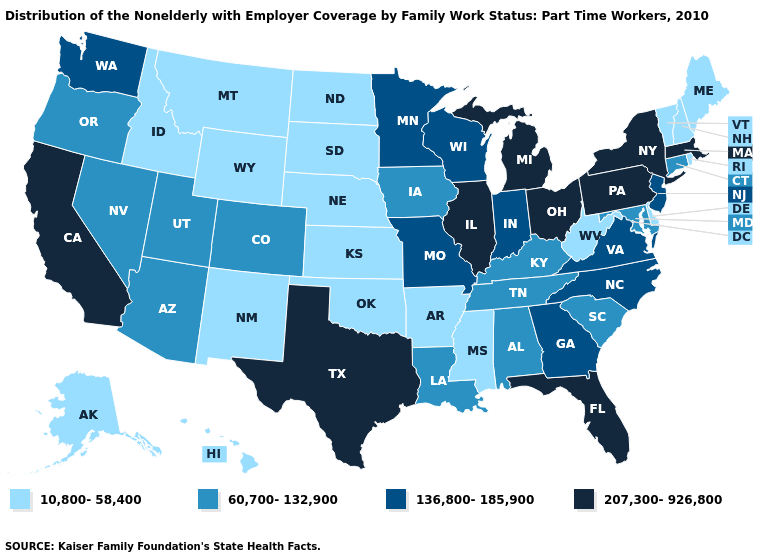What is the lowest value in the Northeast?
Be succinct. 10,800-58,400. How many symbols are there in the legend?
Write a very short answer. 4. What is the value of Arizona?
Answer briefly. 60,700-132,900. Which states have the lowest value in the USA?
Short answer required. Alaska, Arkansas, Delaware, Hawaii, Idaho, Kansas, Maine, Mississippi, Montana, Nebraska, New Hampshire, New Mexico, North Dakota, Oklahoma, Rhode Island, South Dakota, Vermont, West Virginia, Wyoming. Among the states that border Maryland , does Delaware have the lowest value?
Write a very short answer. Yes. How many symbols are there in the legend?
Answer briefly. 4. Which states have the lowest value in the West?
Answer briefly. Alaska, Hawaii, Idaho, Montana, New Mexico, Wyoming. Does Nebraska have the lowest value in the USA?
Write a very short answer. Yes. Is the legend a continuous bar?
Be succinct. No. How many symbols are there in the legend?
Keep it brief. 4. Which states have the highest value in the USA?
Short answer required. California, Florida, Illinois, Massachusetts, Michigan, New York, Ohio, Pennsylvania, Texas. Does Pennsylvania have the lowest value in the USA?
Answer briefly. No. Is the legend a continuous bar?
Be succinct. No. What is the value of Connecticut?
Concise answer only. 60,700-132,900. What is the highest value in the Northeast ?
Write a very short answer. 207,300-926,800. 